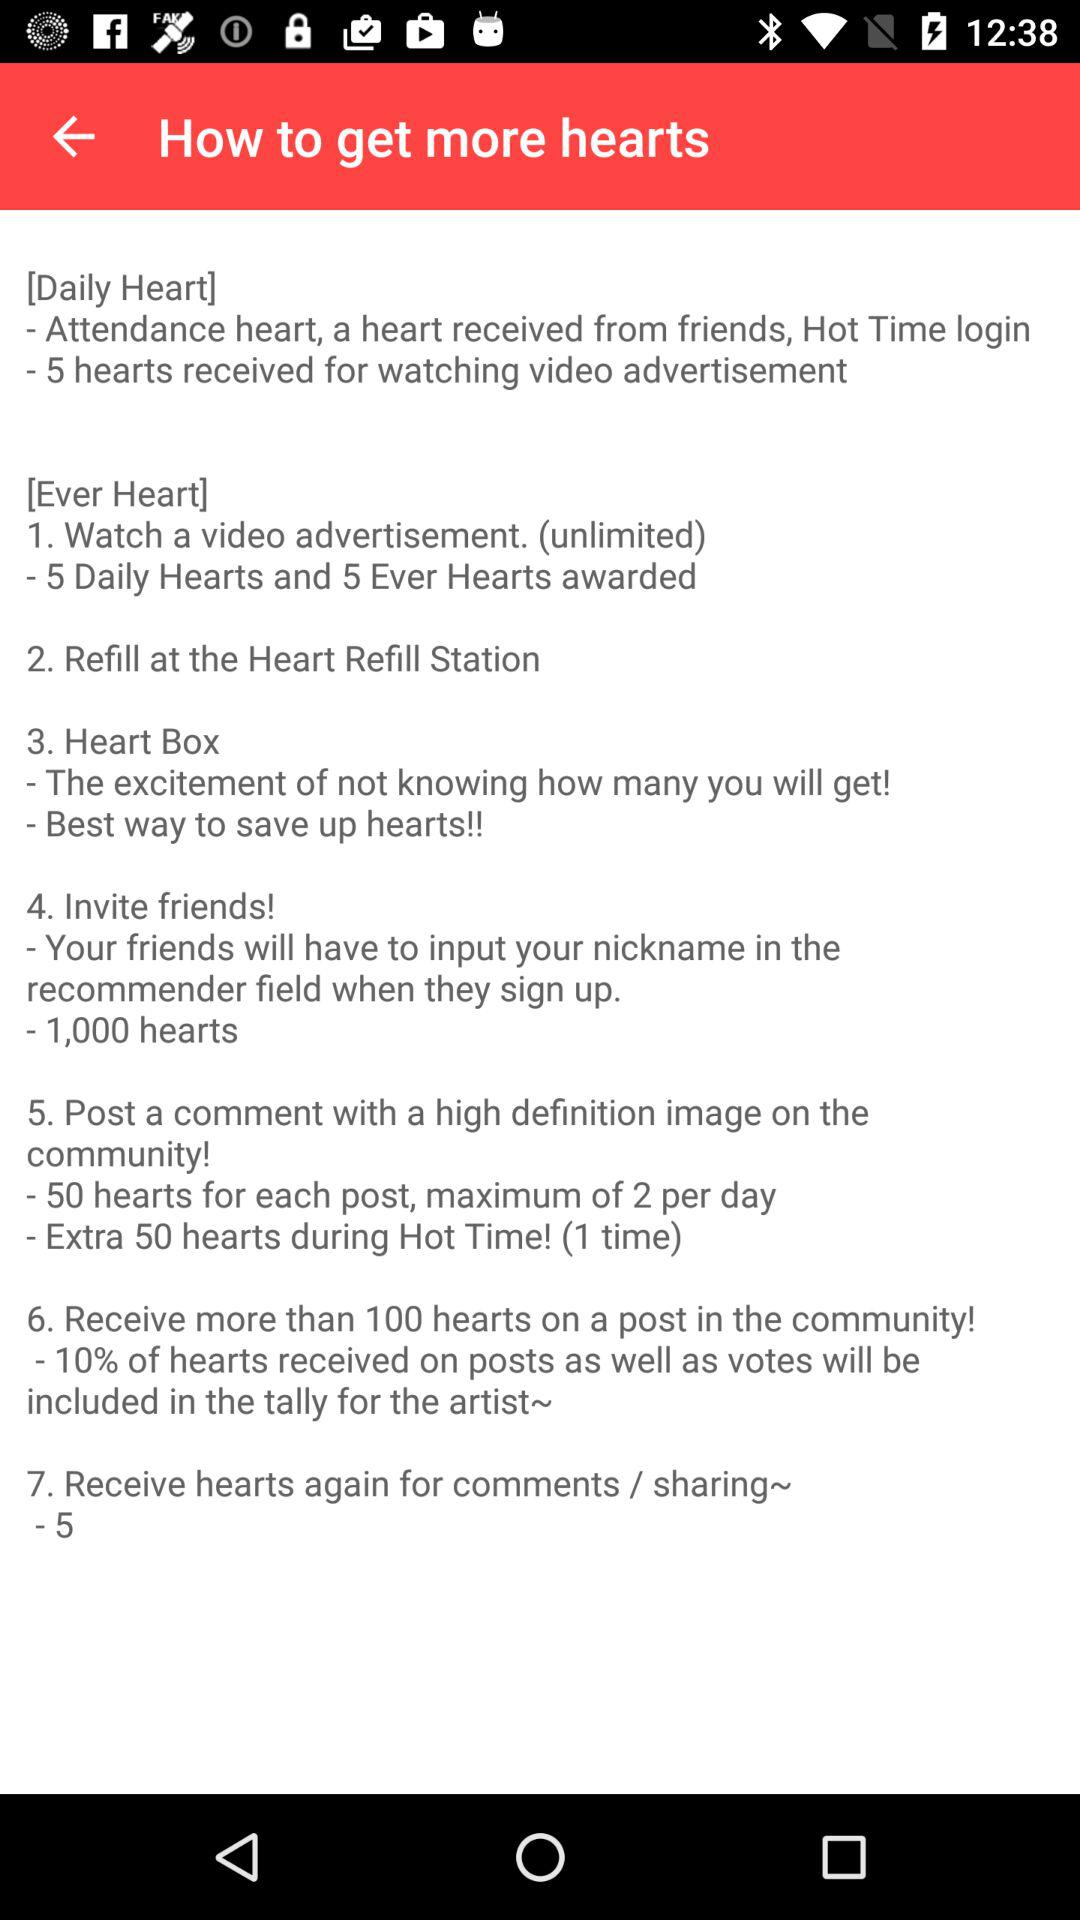How many hearts can you earn for watching a video advertisement?
Answer the question using a single word or phrase. 5 